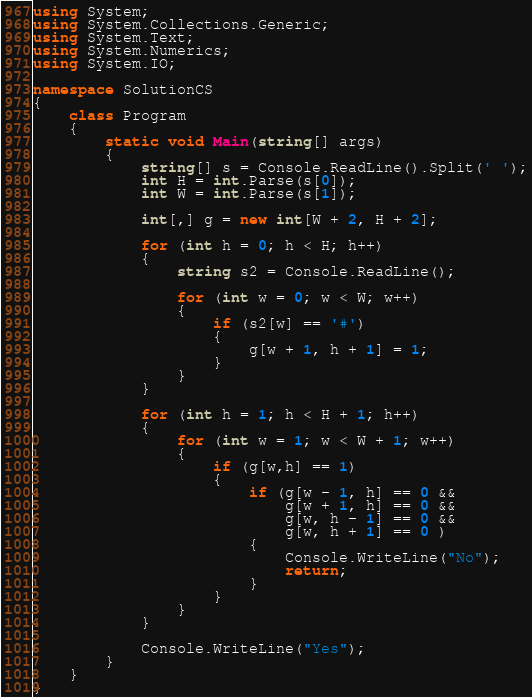<code> <loc_0><loc_0><loc_500><loc_500><_C#_>using System;
using System.Collections.Generic;
using System.Text;
using System.Numerics;
using System.IO;

namespace SolutionCS
{
    class Program
    {
        static void Main(string[] args)
        {
            string[] s = Console.ReadLine().Split(' ');
            int H = int.Parse(s[0]);
            int W = int.Parse(s[1]);

            int[,] g = new int[W + 2, H + 2];

            for (int h = 0; h < H; h++)
            {
                string s2 = Console.ReadLine();

                for (int w = 0; w < W; w++)
                {
                    if (s2[w] == '#')
                    {
                        g[w + 1, h + 1] = 1;
                    }
                }
            }

            for (int h = 1; h < H + 1; h++)
            {
                for (int w = 1; w < W + 1; w++)
                {
                    if (g[w,h] == 1)
                    {
                        if (g[w - 1, h] == 0 &&
                            g[w + 1, h] == 0 &&
                            g[w, h - 1] == 0 &&
                            g[w, h + 1] == 0 )
                        {
                            Console.WriteLine("No");
                            return;
                        }
                    }
                }
            }

            Console.WriteLine("Yes");
        }
    }
}
</code> 